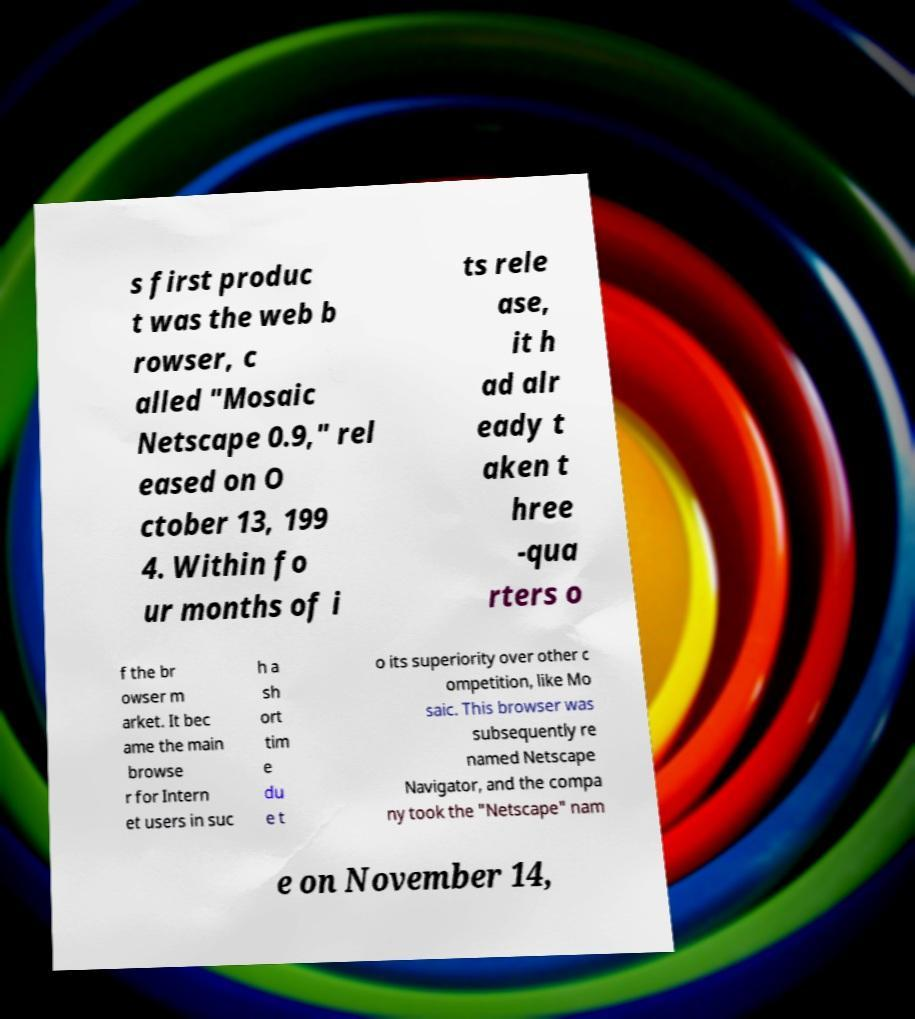Can you accurately transcribe the text from the provided image for me? s first produc t was the web b rowser, c alled "Mosaic Netscape 0.9," rel eased on O ctober 13, 199 4. Within fo ur months of i ts rele ase, it h ad alr eady t aken t hree -qua rters o f the br owser m arket. It bec ame the main browse r for Intern et users in suc h a sh ort tim e du e t o its superiority over other c ompetition, like Mo saic. This browser was subsequently re named Netscape Navigator, and the compa ny took the "Netscape" nam e on November 14, 